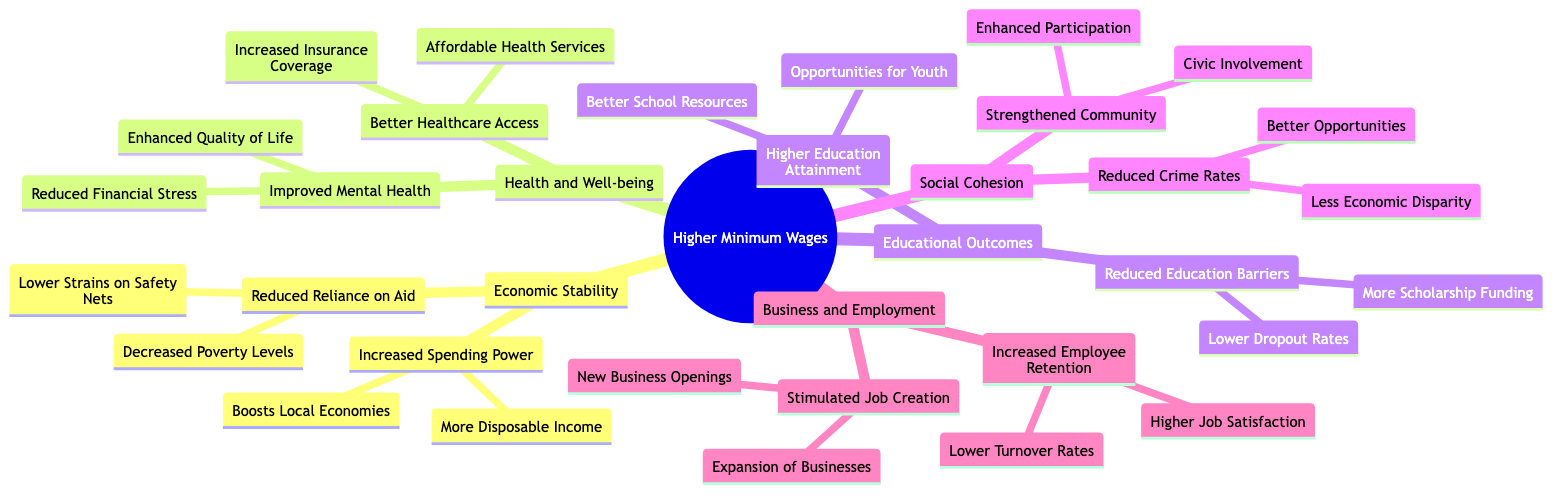What is the main category represented at the root of the mind map? The root of the mind map is labeled "Higher Minimum Wages," indicating that all discussed topics stem from this central theme.
Answer: Higher Minimum Wages How many primary categories are listed under the root? There are five primary categories branching out from the root: Economic Stability, Health and Well-being, Educational Outcomes, Social Cohesion, and Business and Employment.
Answer: 5 What is one benefit of increased spending power mentioned in the diagram? Under the "Increased Spending Power" section, "Boosts Local Economies" is listed as a benefit, indicating that higher spending power contributes positively to the local economy.
Answer: Boosts Local Economies Which section includes "Reduced Financial Stress"? The "Improved Mental Health" section under "Health and Well-being" mentions "Reduced Financial Stress," highlighting a mental health benefit related to economic conditions.
Answer: Health and Well-being What are two outcomes of reduced reliance on public assistance? The "Reduced Reliance on Aid" section outlines "Lower Strains on Safety Nets" and "Decreased Poverty Levels" as outcomes, showing how higher wages can alleviate the need for government assistance.
Answer: Lower Strains on Safety Nets, Decreased Poverty Levels Which benefits are associated with stronger community bonds? The "Strengthened Community" section lists "Enhanced Participation" and "Civic Involvement," illustrating the social benefits of stronger community bonds due to higher wages.
Answer: Enhanced Participation, Civic Involvement Why might higher education attainment lead to lower dropout rates? Higher educational attainment, indicated in the "Higher Education Attainment" section, creates "More Opportunities for Youth," which likely contributes to "Lower Dropout Rates" by providing better prospects for students.
Answer: More Opportunities for Youth How does higher minimum wage contribute to business and employment? The "Business and Employment" section states that higher minimum wages lead to "Increased Employee Retention" and "Stimulated Job Creation," suggesting a positive impact on the workforce.
Answer: Increased Employee Retention, Stimulated Job Creation 